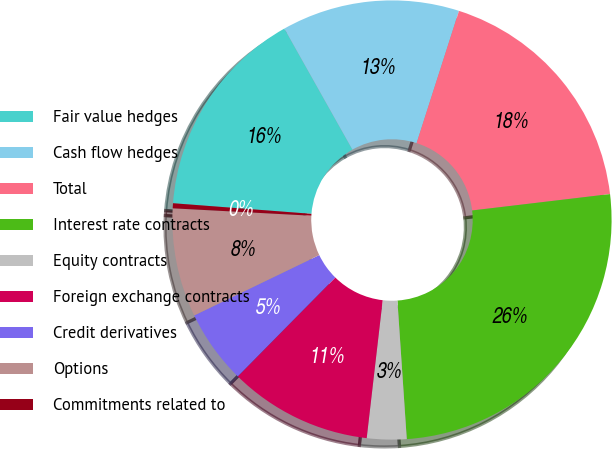Convert chart. <chart><loc_0><loc_0><loc_500><loc_500><pie_chart><fcel>Fair value hedges<fcel>Cash flow hedges<fcel>Total<fcel>Interest rate contracts<fcel>Equity contracts<fcel>Foreign exchange contracts<fcel>Credit derivatives<fcel>Options<fcel>Commitments related to<nl><fcel>15.63%<fcel>13.09%<fcel>18.18%<fcel>25.81%<fcel>2.91%<fcel>10.55%<fcel>5.46%<fcel>8.0%<fcel>0.37%<nl></chart> 